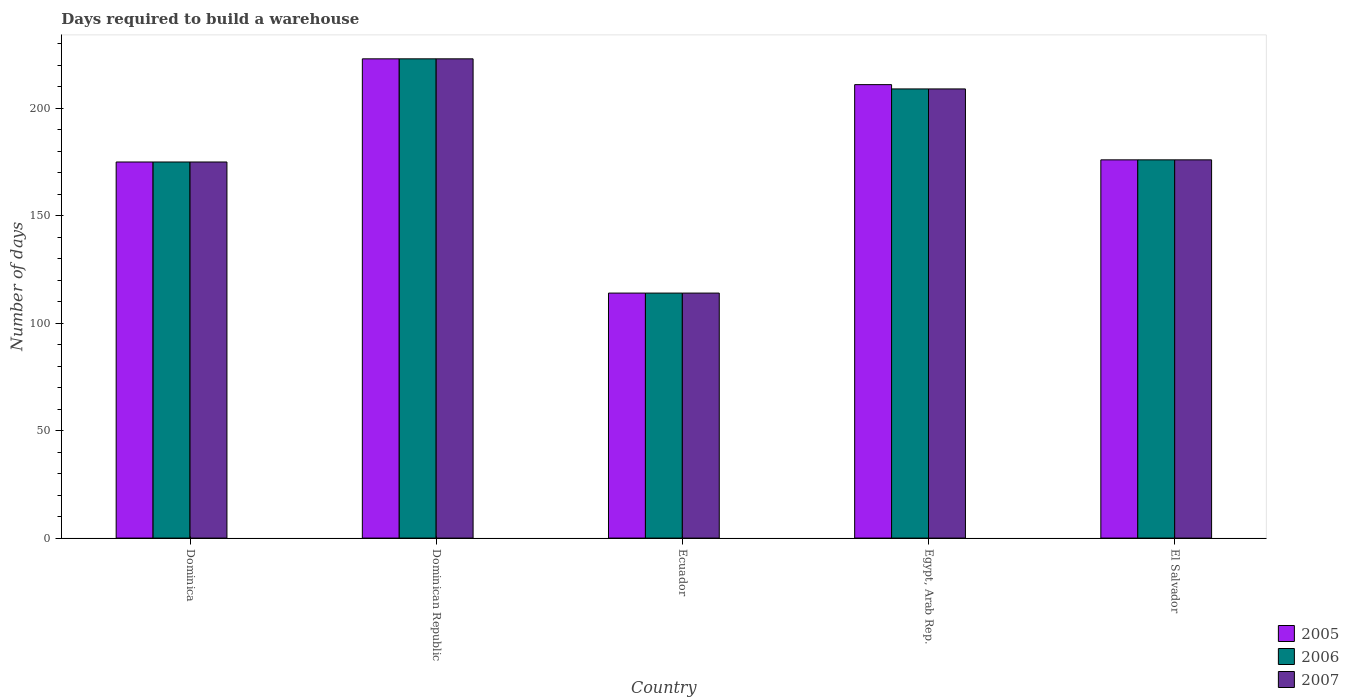How many different coloured bars are there?
Keep it short and to the point. 3. How many bars are there on the 3rd tick from the left?
Provide a short and direct response. 3. What is the label of the 2nd group of bars from the left?
Your answer should be compact. Dominican Republic. What is the days required to build a warehouse in in 2005 in Egypt, Arab Rep.?
Your response must be concise. 211. Across all countries, what is the maximum days required to build a warehouse in in 2007?
Ensure brevity in your answer.  223. Across all countries, what is the minimum days required to build a warehouse in in 2007?
Offer a terse response. 114. In which country was the days required to build a warehouse in in 2006 maximum?
Make the answer very short. Dominican Republic. In which country was the days required to build a warehouse in in 2007 minimum?
Give a very brief answer. Ecuador. What is the total days required to build a warehouse in in 2005 in the graph?
Your response must be concise. 899. What is the difference between the days required to build a warehouse in in 2005 in Egypt, Arab Rep. and that in El Salvador?
Ensure brevity in your answer.  35. What is the average days required to build a warehouse in in 2006 per country?
Your answer should be very brief. 179.4. What is the ratio of the days required to build a warehouse in in 2006 in Dominican Republic to that in El Salvador?
Offer a terse response. 1.27. What is the difference between the highest and the second highest days required to build a warehouse in in 2007?
Your answer should be compact. -33. What is the difference between the highest and the lowest days required to build a warehouse in in 2005?
Ensure brevity in your answer.  109. In how many countries, is the days required to build a warehouse in in 2005 greater than the average days required to build a warehouse in in 2005 taken over all countries?
Offer a very short reply. 2. Is the sum of the days required to build a warehouse in in 2007 in Dominica and Ecuador greater than the maximum days required to build a warehouse in in 2005 across all countries?
Provide a short and direct response. Yes. Is it the case that in every country, the sum of the days required to build a warehouse in in 2005 and days required to build a warehouse in in 2006 is greater than the days required to build a warehouse in in 2007?
Your answer should be compact. Yes. How many countries are there in the graph?
Offer a terse response. 5. What is the difference between two consecutive major ticks on the Y-axis?
Your answer should be very brief. 50. Does the graph contain grids?
Offer a terse response. No. Where does the legend appear in the graph?
Provide a succinct answer. Bottom right. How many legend labels are there?
Give a very brief answer. 3. What is the title of the graph?
Offer a terse response. Days required to build a warehouse. What is the label or title of the X-axis?
Ensure brevity in your answer.  Country. What is the label or title of the Y-axis?
Make the answer very short. Number of days. What is the Number of days in 2005 in Dominica?
Your answer should be very brief. 175. What is the Number of days of 2006 in Dominica?
Offer a very short reply. 175. What is the Number of days in 2007 in Dominica?
Ensure brevity in your answer.  175. What is the Number of days in 2005 in Dominican Republic?
Provide a short and direct response. 223. What is the Number of days of 2006 in Dominican Republic?
Keep it short and to the point. 223. What is the Number of days of 2007 in Dominican Republic?
Make the answer very short. 223. What is the Number of days in 2005 in Ecuador?
Keep it short and to the point. 114. What is the Number of days of 2006 in Ecuador?
Offer a terse response. 114. What is the Number of days in 2007 in Ecuador?
Your answer should be compact. 114. What is the Number of days of 2005 in Egypt, Arab Rep.?
Offer a terse response. 211. What is the Number of days in 2006 in Egypt, Arab Rep.?
Your answer should be very brief. 209. What is the Number of days of 2007 in Egypt, Arab Rep.?
Provide a short and direct response. 209. What is the Number of days in 2005 in El Salvador?
Offer a terse response. 176. What is the Number of days in 2006 in El Salvador?
Provide a short and direct response. 176. What is the Number of days of 2007 in El Salvador?
Keep it short and to the point. 176. Across all countries, what is the maximum Number of days of 2005?
Ensure brevity in your answer.  223. Across all countries, what is the maximum Number of days of 2006?
Make the answer very short. 223. Across all countries, what is the maximum Number of days of 2007?
Offer a very short reply. 223. Across all countries, what is the minimum Number of days in 2005?
Keep it short and to the point. 114. Across all countries, what is the minimum Number of days of 2006?
Offer a very short reply. 114. Across all countries, what is the minimum Number of days in 2007?
Offer a very short reply. 114. What is the total Number of days of 2005 in the graph?
Provide a succinct answer. 899. What is the total Number of days of 2006 in the graph?
Your answer should be very brief. 897. What is the total Number of days in 2007 in the graph?
Your response must be concise. 897. What is the difference between the Number of days of 2005 in Dominica and that in Dominican Republic?
Ensure brevity in your answer.  -48. What is the difference between the Number of days in 2006 in Dominica and that in Dominican Republic?
Keep it short and to the point. -48. What is the difference between the Number of days of 2007 in Dominica and that in Dominican Republic?
Keep it short and to the point. -48. What is the difference between the Number of days in 2007 in Dominica and that in Ecuador?
Provide a succinct answer. 61. What is the difference between the Number of days of 2005 in Dominica and that in Egypt, Arab Rep.?
Give a very brief answer. -36. What is the difference between the Number of days in 2006 in Dominica and that in Egypt, Arab Rep.?
Make the answer very short. -34. What is the difference between the Number of days of 2007 in Dominica and that in Egypt, Arab Rep.?
Make the answer very short. -34. What is the difference between the Number of days in 2005 in Dominica and that in El Salvador?
Offer a very short reply. -1. What is the difference between the Number of days in 2005 in Dominican Republic and that in Ecuador?
Provide a succinct answer. 109. What is the difference between the Number of days of 2006 in Dominican Republic and that in Ecuador?
Provide a short and direct response. 109. What is the difference between the Number of days in 2007 in Dominican Republic and that in Ecuador?
Provide a succinct answer. 109. What is the difference between the Number of days of 2005 in Dominican Republic and that in Egypt, Arab Rep.?
Your answer should be very brief. 12. What is the difference between the Number of days of 2006 in Dominican Republic and that in Egypt, Arab Rep.?
Your answer should be very brief. 14. What is the difference between the Number of days in 2007 in Dominican Republic and that in Egypt, Arab Rep.?
Ensure brevity in your answer.  14. What is the difference between the Number of days of 2006 in Dominican Republic and that in El Salvador?
Provide a short and direct response. 47. What is the difference between the Number of days of 2007 in Dominican Republic and that in El Salvador?
Provide a succinct answer. 47. What is the difference between the Number of days of 2005 in Ecuador and that in Egypt, Arab Rep.?
Make the answer very short. -97. What is the difference between the Number of days of 2006 in Ecuador and that in Egypt, Arab Rep.?
Give a very brief answer. -95. What is the difference between the Number of days in 2007 in Ecuador and that in Egypt, Arab Rep.?
Provide a short and direct response. -95. What is the difference between the Number of days of 2005 in Ecuador and that in El Salvador?
Make the answer very short. -62. What is the difference between the Number of days in 2006 in Ecuador and that in El Salvador?
Your response must be concise. -62. What is the difference between the Number of days in 2007 in Ecuador and that in El Salvador?
Your answer should be compact. -62. What is the difference between the Number of days of 2007 in Egypt, Arab Rep. and that in El Salvador?
Keep it short and to the point. 33. What is the difference between the Number of days in 2005 in Dominica and the Number of days in 2006 in Dominican Republic?
Keep it short and to the point. -48. What is the difference between the Number of days in 2005 in Dominica and the Number of days in 2007 in Dominican Republic?
Provide a short and direct response. -48. What is the difference between the Number of days in 2006 in Dominica and the Number of days in 2007 in Dominican Republic?
Make the answer very short. -48. What is the difference between the Number of days in 2005 in Dominica and the Number of days in 2006 in Ecuador?
Keep it short and to the point. 61. What is the difference between the Number of days of 2005 in Dominica and the Number of days of 2007 in Ecuador?
Ensure brevity in your answer.  61. What is the difference between the Number of days in 2005 in Dominica and the Number of days in 2006 in Egypt, Arab Rep.?
Keep it short and to the point. -34. What is the difference between the Number of days in 2005 in Dominica and the Number of days in 2007 in Egypt, Arab Rep.?
Your response must be concise. -34. What is the difference between the Number of days in 2006 in Dominica and the Number of days in 2007 in Egypt, Arab Rep.?
Make the answer very short. -34. What is the difference between the Number of days in 2005 in Dominica and the Number of days in 2006 in El Salvador?
Provide a short and direct response. -1. What is the difference between the Number of days in 2006 in Dominica and the Number of days in 2007 in El Salvador?
Your answer should be compact. -1. What is the difference between the Number of days in 2005 in Dominican Republic and the Number of days in 2006 in Ecuador?
Give a very brief answer. 109. What is the difference between the Number of days of 2005 in Dominican Republic and the Number of days of 2007 in Ecuador?
Give a very brief answer. 109. What is the difference between the Number of days of 2006 in Dominican Republic and the Number of days of 2007 in Ecuador?
Offer a terse response. 109. What is the difference between the Number of days in 2005 in Dominican Republic and the Number of days in 2006 in Egypt, Arab Rep.?
Give a very brief answer. 14. What is the difference between the Number of days in 2005 in Dominican Republic and the Number of days in 2007 in El Salvador?
Your response must be concise. 47. What is the difference between the Number of days in 2006 in Dominican Republic and the Number of days in 2007 in El Salvador?
Make the answer very short. 47. What is the difference between the Number of days of 2005 in Ecuador and the Number of days of 2006 in Egypt, Arab Rep.?
Offer a terse response. -95. What is the difference between the Number of days of 2005 in Ecuador and the Number of days of 2007 in Egypt, Arab Rep.?
Your answer should be compact. -95. What is the difference between the Number of days of 2006 in Ecuador and the Number of days of 2007 in Egypt, Arab Rep.?
Offer a very short reply. -95. What is the difference between the Number of days of 2005 in Ecuador and the Number of days of 2006 in El Salvador?
Keep it short and to the point. -62. What is the difference between the Number of days in 2005 in Ecuador and the Number of days in 2007 in El Salvador?
Your answer should be compact. -62. What is the difference between the Number of days of 2006 in Ecuador and the Number of days of 2007 in El Salvador?
Ensure brevity in your answer.  -62. What is the difference between the Number of days of 2005 in Egypt, Arab Rep. and the Number of days of 2006 in El Salvador?
Your answer should be compact. 35. What is the average Number of days in 2005 per country?
Provide a short and direct response. 179.8. What is the average Number of days in 2006 per country?
Make the answer very short. 179.4. What is the average Number of days of 2007 per country?
Provide a short and direct response. 179.4. What is the difference between the Number of days in 2005 and Number of days in 2007 in Dominica?
Provide a short and direct response. 0. What is the difference between the Number of days of 2005 and Number of days of 2006 in Ecuador?
Give a very brief answer. 0. What is the difference between the Number of days in 2006 and Number of days in 2007 in Ecuador?
Your answer should be very brief. 0. What is the difference between the Number of days of 2005 and Number of days of 2006 in Egypt, Arab Rep.?
Give a very brief answer. 2. What is the difference between the Number of days in 2005 and Number of days in 2007 in El Salvador?
Provide a succinct answer. 0. What is the ratio of the Number of days in 2005 in Dominica to that in Dominican Republic?
Provide a short and direct response. 0.78. What is the ratio of the Number of days of 2006 in Dominica to that in Dominican Republic?
Offer a very short reply. 0.78. What is the ratio of the Number of days in 2007 in Dominica to that in Dominican Republic?
Give a very brief answer. 0.78. What is the ratio of the Number of days in 2005 in Dominica to that in Ecuador?
Offer a very short reply. 1.54. What is the ratio of the Number of days in 2006 in Dominica to that in Ecuador?
Give a very brief answer. 1.54. What is the ratio of the Number of days of 2007 in Dominica to that in Ecuador?
Provide a succinct answer. 1.54. What is the ratio of the Number of days of 2005 in Dominica to that in Egypt, Arab Rep.?
Ensure brevity in your answer.  0.83. What is the ratio of the Number of days of 2006 in Dominica to that in Egypt, Arab Rep.?
Make the answer very short. 0.84. What is the ratio of the Number of days in 2007 in Dominica to that in Egypt, Arab Rep.?
Your answer should be very brief. 0.84. What is the ratio of the Number of days in 2005 in Dominica to that in El Salvador?
Ensure brevity in your answer.  0.99. What is the ratio of the Number of days in 2005 in Dominican Republic to that in Ecuador?
Provide a short and direct response. 1.96. What is the ratio of the Number of days in 2006 in Dominican Republic to that in Ecuador?
Keep it short and to the point. 1.96. What is the ratio of the Number of days of 2007 in Dominican Republic to that in Ecuador?
Make the answer very short. 1.96. What is the ratio of the Number of days of 2005 in Dominican Republic to that in Egypt, Arab Rep.?
Give a very brief answer. 1.06. What is the ratio of the Number of days of 2006 in Dominican Republic to that in Egypt, Arab Rep.?
Provide a succinct answer. 1.07. What is the ratio of the Number of days of 2007 in Dominican Republic to that in Egypt, Arab Rep.?
Ensure brevity in your answer.  1.07. What is the ratio of the Number of days in 2005 in Dominican Republic to that in El Salvador?
Offer a terse response. 1.27. What is the ratio of the Number of days of 2006 in Dominican Republic to that in El Salvador?
Offer a terse response. 1.27. What is the ratio of the Number of days of 2007 in Dominican Republic to that in El Salvador?
Your answer should be very brief. 1.27. What is the ratio of the Number of days of 2005 in Ecuador to that in Egypt, Arab Rep.?
Give a very brief answer. 0.54. What is the ratio of the Number of days in 2006 in Ecuador to that in Egypt, Arab Rep.?
Your answer should be compact. 0.55. What is the ratio of the Number of days of 2007 in Ecuador to that in Egypt, Arab Rep.?
Your answer should be very brief. 0.55. What is the ratio of the Number of days of 2005 in Ecuador to that in El Salvador?
Give a very brief answer. 0.65. What is the ratio of the Number of days of 2006 in Ecuador to that in El Salvador?
Offer a terse response. 0.65. What is the ratio of the Number of days in 2007 in Ecuador to that in El Salvador?
Keep it short and to the point. 0.65. What is the ratio of the Number of days in 2005 in Egypt, Arab Rep. to that in El Salvador?
Ensure brevity in your answer.  1.2. What is the ratio of the Number of days of 2006 in Egypt, Arab Rep. to that in El Salvador?
Offer a terse response. 1.19. What is the ratio of the Number of days in 2007 in Egypt, Arab Rep. to that in El Salvador?
Your answer should be compact. 1.19. What is the difference between the highest and the second highest Number of days in 2006?
Provide a succinct answer. 14. What is the difference between the highest and the second highest Number of days in 2007?
Your response must be concise. 14. What is the difference between the highest and the lowest Number of days in 2005?
Your answer should be very brief. 109. What is the difference between the highest and the lowest Number of days of 2006?
Provide a short and direct response. 109. What is the difference between the highest and the lowest Number of days of 2007?
Give a very brief answer. 109. 